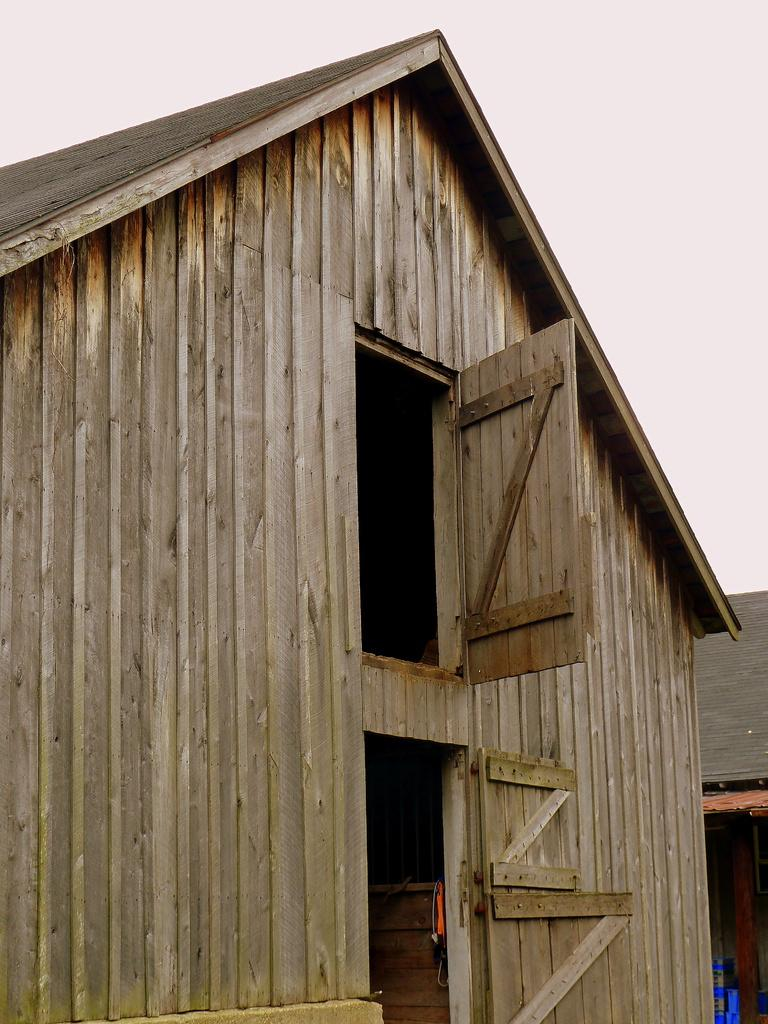What type of structures are present in the image? There are shacks in the image. What color is the prominent object in the image? There is an orange-colored object in the image. What color are the objects in the background of the image? There are blue objects in the background of the image. Can you identify any openings or entrances in the image? There are doors visible in the image. How many sticks are being used to help build the shacks in the image? There is no mention of sticks being used to build the shacks in the image. What type of pickle can be seen on the door of the shack? There is no pickle present in the image. 